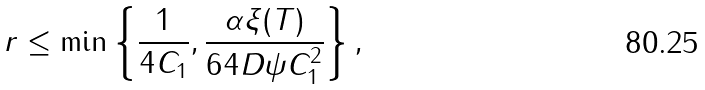<formula> <loc_0><loc_0><loc_500><loc_500>r \leq \min \left \{ \frac { 1 } { 4 C _ { 1 } } , \frac { \alpha \xi ( T ) } { 6 4 D \psi C _ { 1 } ^ { 2 } } \right \} ,</formula> 